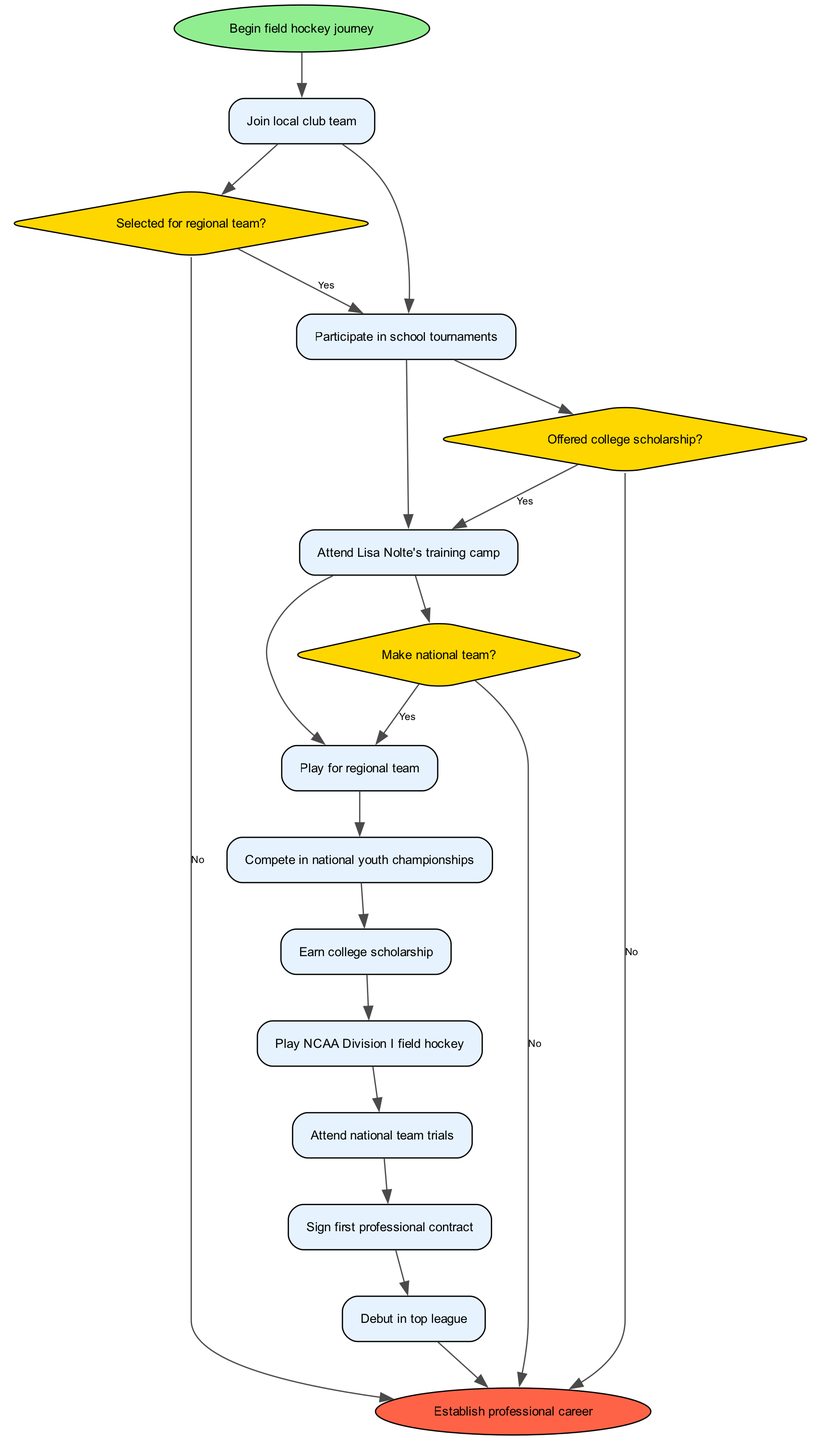What is the starting point of the journey? The journey begins with the node labeled "Begin field hockey journey." This is the first node in the diagram, indicating the initiation of the process.
Answer: Begin field hockey journey How many activities are listed in the diagram? The diagram contains a total of ten activities represented by the nodes labeled "Join local club team," "Participate in school tournaments," "Attend Lisa Nolte's training camp," "Play for regional team," "Compete in national youth championships," "Earn college scholarship," "Play NCAA Division I field hockey," "Attend national team trials," "Sign first professional contract," and "Debut in top league." Counting these gives a total of ten activities.
Answer: 10 What decision must be made after participating in a school tournament? After participating in a school tournament, the next decision node is "Selected for regional team?" This decision impacts the player's progression toward becoming a professional.
Answer: Selected for regional team? What is the final step in the career journey of the player? The final step in the journey is represented by the node labeled "Establish professional career." This indicates the completion of the transition from amateur to professional status.
Answer: Establish professional career How does a player move from playing for a regional team to competing in national youth championships? The transition from "Play for regional team" to "Compete in national youth championships" occurs if the decision "Selected for regional team?" results in a "Yes." This connection is established by the directed edge between these two nodes in the diagram.
Answer: Yes What outcome results if the player is not offered a college scholarship? If the decision labeled "Offered college scholarship?" results in a "No," the progression would lead to the end node "Establish professional career" indicating that without this scholarship, the player would not continue through the collegiate path which leads to professional opportunities.
Answer: No At which point does the player attend national team trials? The player attends national team trials after successfully completing "Play NCAA Division I field hockey." This progression of nodes shows the specific order of steps leading to this opportunity.
Answer: Play NCAA Division I field hockey What action follows after "Sign first professional contract"? After signing the first professional contract, the next action is to "Debut in top league," showing the natural progression towards professional competition following contract signing.
Answer: Debut in top league 